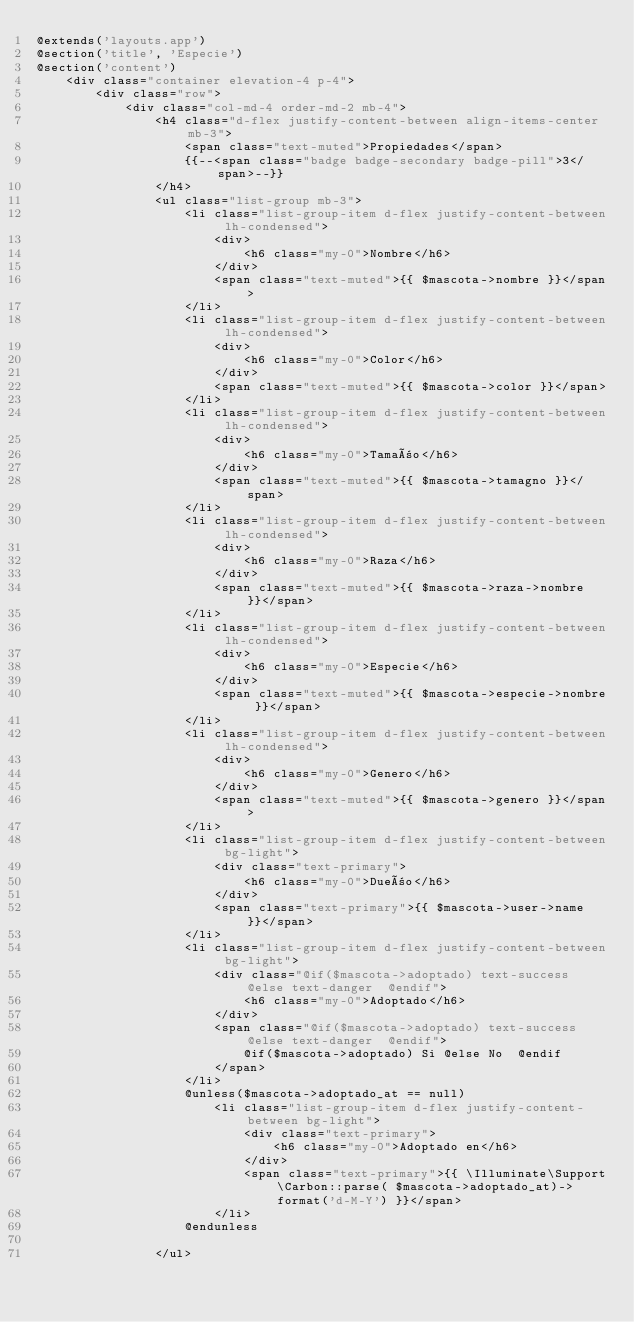Convert code to text. <code><loc_0><loc_0><loc_500><loc_500><_PHP_>@extends('layouts.app')
@section('title', 'Especie')
@section('content')
    <div class="container elevation-4 p-4">
        <div class="row">
            <div class="col-md-4 order-md-2 mb-4">
                <h4 class="d-flex justify-content-between align-items-center mb-3">
                    <span class="text-muted">Propiedades</span>
                    {{--<span class="badge badge-secondary badge-pill">3</span>--}}
                </h4>
                <ul class="list-group mb-3">
                    <li class="list-group-item d-flex justify-content-between lh-condensed">
                        <div>
                            <h6 class="my-0">Nombre</h6>
                        </div>
                        <span class="text-muted">{{ $mascota->nombre }}</span>
                    </li>
                    <li class="list-group-item d-flex justify-content-between lh-condensed">
                        <div>
                            <h6 class="my-0">Color</h6>
                        </div>
                        <span class="text-muted">{{ $mascota->color }}</span>
                    </li>
                    <li class="list-group-item d-flex justify-content-between lh-condensed">
                        <div>
                            <h6 class="my-0">Tamaño</h6>
                        </div>
                        <span class="text-muted">{{ $mascota->tamagno }}</span>
                    </li>
                    <li class="list-group-item d-flex justify-content-between lh-condensed">
                        <div>
                            <h6 class="my-0">Raza</h6>
                        </div>
                        <span class="text-muted">{{ $mascota->raza->nombre }}</span>
                    </li>
                    <li class="list-group-item d-flex justify-content-between lh-condensed">
                        <div>
                            <h6 class="my-0">Especie</h6>
                        </div>
                        <span class="text-muted">{{ $mascota->especie->nombre }}</span>
                    </li>
                    <li class="list-group-item d-flex justify-content-between lh-condensed">
                        <div>
                            <h6 class="my-0">Genero</h6>
                        </div>
                        <span class="text-muted">{{ $mascota->genero }}</span>
                    </li>
                    <li class="list-group-item d-flex justify-content-between bg-light">
                        <div class="text-primary">
                            <h6 class="my-0">Dueño</h6>
                        </div>
                        <span class="text-primary">{{ $mascota->user->name }}</span>
                    </li>
                    <li class="list-group-item d-flex justify-content-between bg-light">
                        <div class="@if($mascota->adoptado) text-success @else text-danger  @endif">
                            <h6 class="my-0">Adoptado</h6>
                        </div>
                        <span class="@if($mascota->adoptado) text-success @else text-danger  @endif">
                            @if($mascota->adoptado) Si @else No  @endif
                        </span>
                    </li>
                    @unless($mascota->adoptado_at == null)
                        <li class="list-group-item d-flex justify-content-between bg-light">
                            <div class="text-primary">
                                <h6 class="my-0">Adoptado en</h6>
                            </div>
                            <span class="text-primary">{{ \Illuminate\Support\Carbon::parse( $mascota->adoptado_at)->format('d-M-Y') }}</span>
                        </li>
                    @endunless

                </ul></code> 